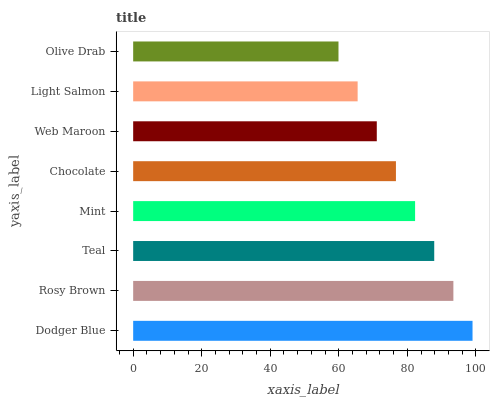Is Olive Drab the minimum?
Answer yes or no. Yes. Is Dodger Blue the maximum?
Answer yes or no. Yes. Is Rosy Brown the minimum?
Answer yes or no. No. Is Rosy Brown the maximum?
Answer yes or no. No. Is Dodger Blue greater than Rosy Brown?
Answer yes or no. Yes. Is Rosy Brown less than Dodger Blue?
Answer yes or no. Yes. Is Rosy Brown greater than Dodger Blue?
Answer yes or no. No. Is Dodger Blue less than Rosy Brown?
Answer yes or no. No. Is Mint the high median?
Answer yes or no. Yes. Is Chocolate the low median?
Answer yes or no. Yes. Is Chocolate the high median?
Answer yes or no. No. Is Dodger Blue the low median?
Answer yes or no. No. 